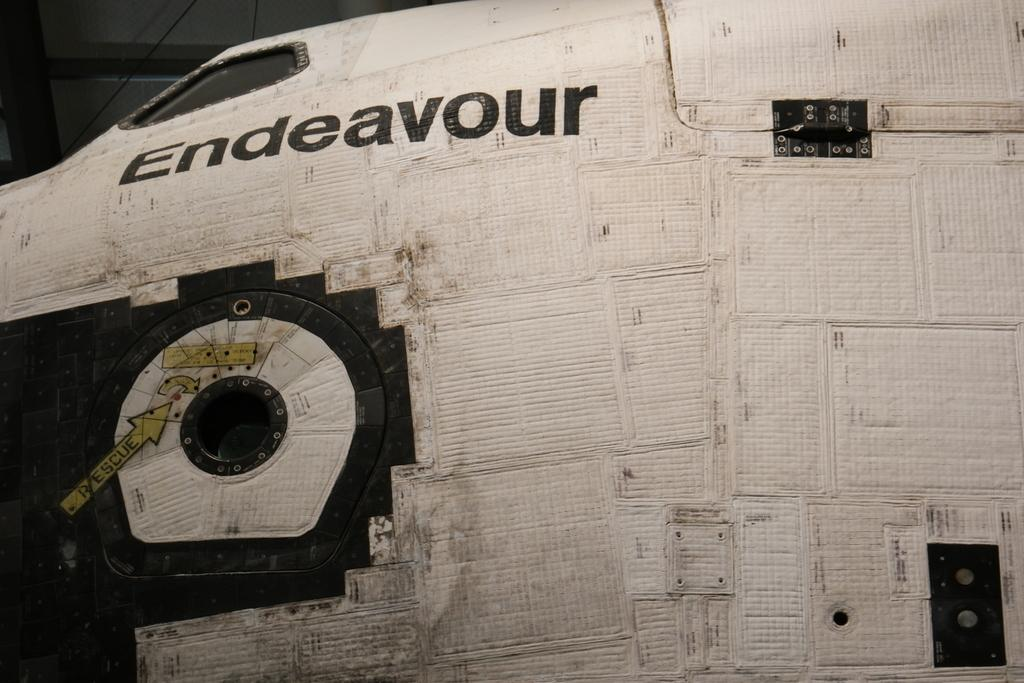Provide a one-sentence caption for the provided image. Endeavour is printed in black on a white surface. 